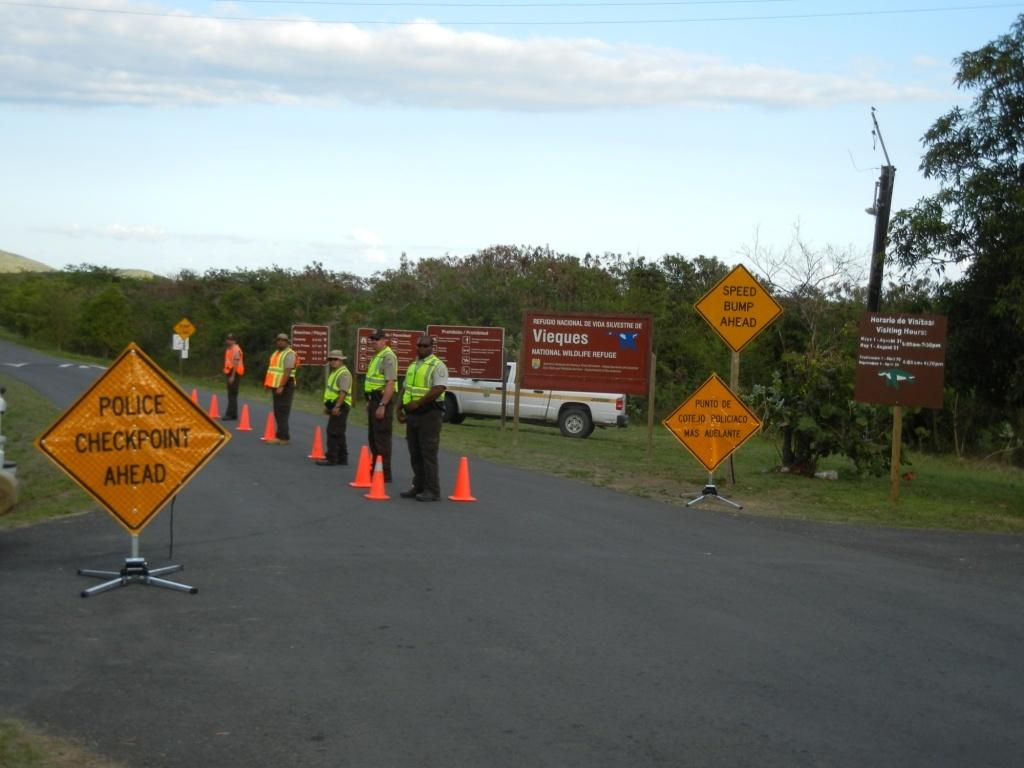Provide a one-sentence caption for the provided image. Several men in safety vests run a police checkpoint. 